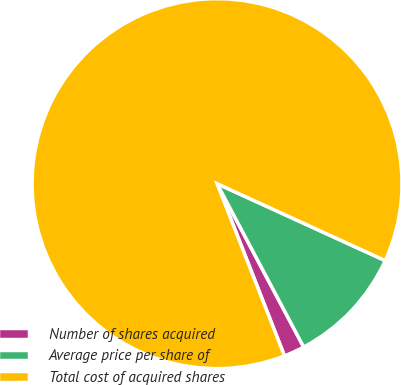<chart> <loc_0><loc_0><loc_500><loc_500><pie_chart><fcel>Number of shares acquired<fcel>Average price per share of<fcel>Total cost of acquired shares<nl><fcel>1.82%<fcel>10.41%<fcel>87.77%<nl></chart> 